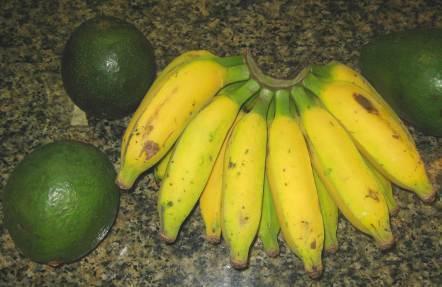How many avocados are in the picture?
Give a very brief answer. 3. How many fruits are here?
Give a very brief answer. 2. How many oranges are in the photo?
Give a very brief answer. 2. How many bikes are shown?
Give a very brief answer. 0. 